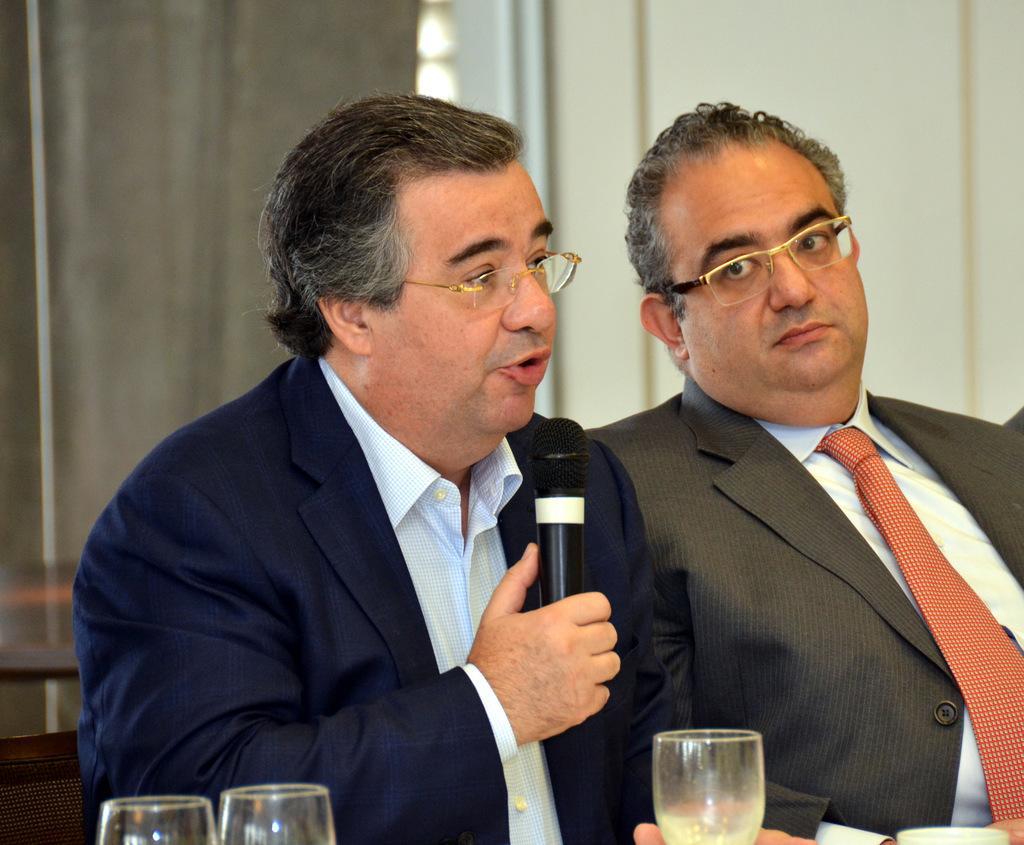Could you give a brief overview of what you see in this image? 2 people are sitting wearing suit. the person at the left is holding a microphone and speaking. in front of them there are glasses. at the back there are curtains and a wall. 